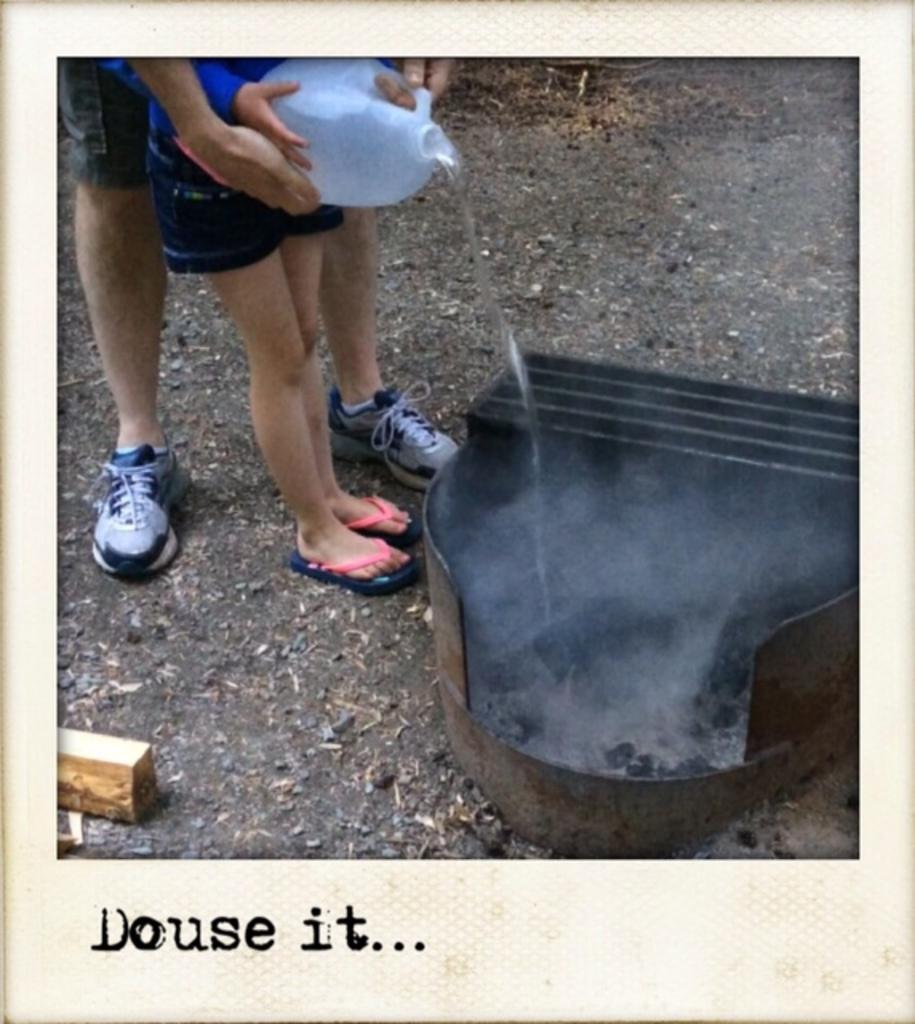In one or two sentences, can you explain what this image depicts? In this image I can see a container on the right side , on the left side there are two persons holding a bottle, pouring a liquid on it, there is a small wooden piece visible in the bottom left, at the bottom there is a text. 